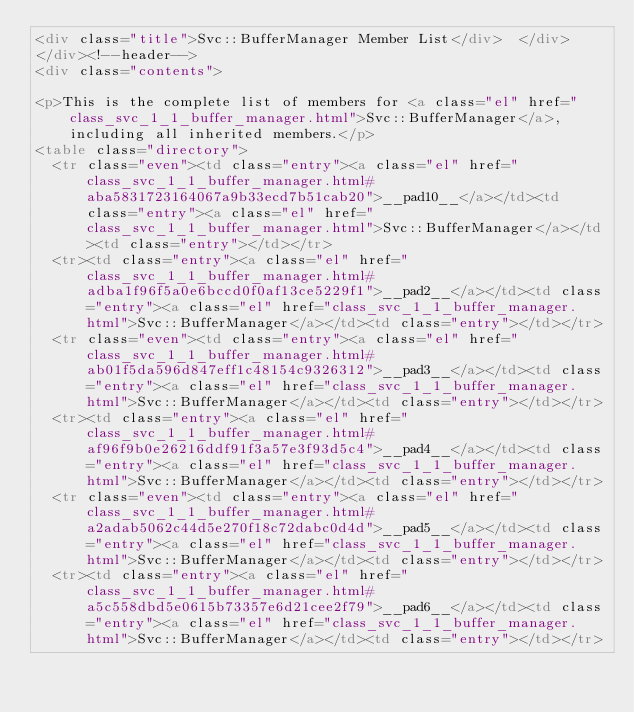Convert code to text. <code><loc_0><loc_0><loc_500><loc_500><_HTML_><div class="title">Svc::BufferManager Member List</div>  </div>
</div><!--header-->
<div class="contents">

<p>This is the complete list of members for <a class="el" href="class_svc_1_1_buffer_manager.html">Svc::BufferManager</a>, including all inherited members.</p>
<table class="directory">
  <tr class="even"><td class="entry"><a class="el" href="class_svc_1_1_buffer_manager.html#aba5831723164067a9b33ecd7b51cab20">__pad10__</a></td><td class="entry"><a class="el" href="class_svc_1_1_buffer_manager.html">Svc::BufferManager</a></td><td class="entry"></td></tr>
  <tr><td class="entry"><a class="el" href="class_svc_1_1_buffer_manager.html#adba1f96f5a0e6bccd0f0af13ce5229f1">__pad2__</a></td><td class="entry"><a class="el" href="class_svc_1_1_buffer_manager.html">Svc::BufferManager</a></td><td class="entry"></td></tr>
  <tr class="even"><td class="entry"><a class="el" href="class_svc_1_1_buffer_manager.html#ab01f5da596d847eff1c48154c9326312">__pad3__</a></td><td class="entry"><a class="el" href="class_svc_1_1_buffer_manager.html">Svc::BufferManager</a></td><td class="entry"></td></tr>
  <tr><td class="entry"><a class="el" href="class_svc_1_1_buffer_manager.html#af96f9b0e26216ddf91f3a57e3f93d5c4">__pad4__</a></td><td class="entry"><a class="el" href="class_svc_1_1_buffer_manager.html">Svc::BufferManager</a></td><td class="entry"></td></tr>
  <tr class="even"><td class="entry"><a class="el" href="class_svc_1_1_buffer_manager.html#a2adab5062c44d5e270f18c72dabc0d4d">__pad5__</a></td><td class="entry"><a class="el" href="class_svc_1_1_buffer_manager.html">Svc::BufferManager</a></td><td class="entry"></td></tr>
  <tr><td class="entry"><a class="el" href="class_svc_1_1_buffer_manager.html#a5c558dbd5e0615b73357e6d21cee2f79">__pad6__</a></td><td class="entry"><a class="el" href="class_svc_1_1_buffer_manager.html">Svc::BufferManager</a></td><td class="entry"></td></tr></code> 